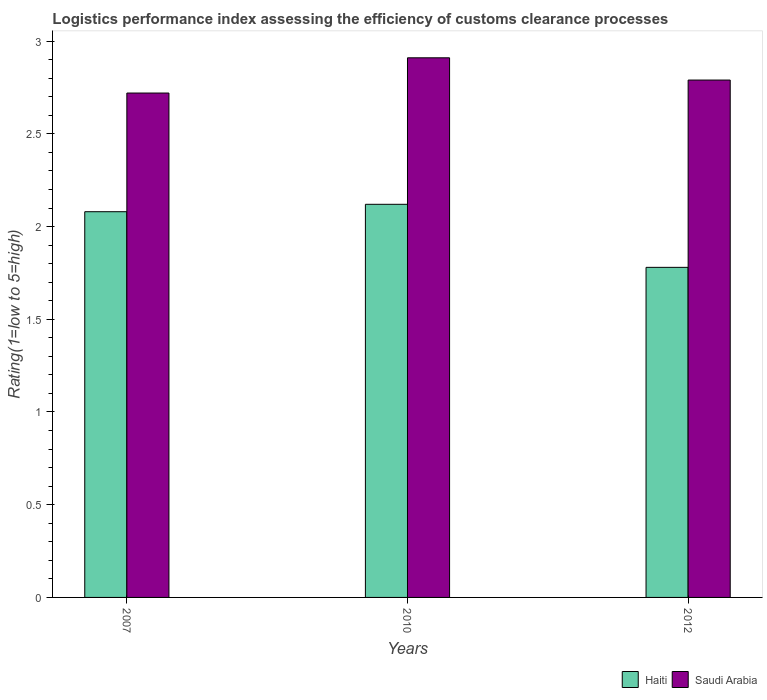How many different coloured bars are there?
Provide a succinct answer. 2. How many bars are there on the 3rd tick from the left?
Offer a very short reply. 2. What is the label of the 2nd group of bars from the left?
Your answer should be very brief. 2010. What is the Logistic performance index in Saudi Arabia in 2012?
Your answer should be compact. 2.79. Across all years, what is the maximum Logistic performance index in Saudi Arabia?
Provide a short and direct response. 2.91. Across all years, what is the minimum Logistic performance index in Haiti?
Give a very brief answer. 1.78. What is the total Logistic performance index in Saudi Arabia in the graph?
Make the answer very short. 8.42. What is the difference between the Logistic performance index in Haiti in 2007 and that in 2010?
Make the answer very short. -0.04. What is the difference between the Logistic performance index in Saudi Arabia in 2010 and the Logistic performance index in Haiti in 2012?
Make the answer very short. 1.13. What is the average Logistic performance index in Saudi Arabia per year?
Provide a succinct answer. 2.81. In the year 2010, what is the difference between the Logistic performance index in Haiti and Logistic performance index in Saudi Arabia?
Your answer should be very brief. -0.79. What is the ratio of the Logistic performance index in Haiti in 2007 to that in 2010?
Ensure brevity in your answer.  0.98. Is the difference between the Logistic performance index in Haiti in 2007 and 2010 greater than the difference between the Logistic performance index in Saudi Arabia in 2007 and 2010?
Give a very brief answer. Yes. What is the difference between the highest and the second highest Logistic performance index in Saudi Arabia?
Offer a terse response. 0.12. What is the difference between the highest and the lowest Logistic performance index in Saudi Arabia?
Your answer should be very brief. 0.19. In how many years, is the Logistic performance index in Haiti greater than the average Logistic performance index in Haiti taken over all years?
Keep it short and to the point. 2. What does the 2nd bar from the left in 2012 represents?
Keep it short and to the point. Saudi Arabia. What does the 2nd bar from the right in 2007 represents?
Offer a terse response. Haiti. How many bars are there?
Your answer should be compact. 6. Are the values on the major ticks of Y-axis written in scientific E-notation?
Provide a succinct answer. No. Where does the legend appear in the graph?
Keep it short and to the point. Bottom right. What is the title of the graph?
Make the answer very short. Logistics performance index assessing the efficiency of customs clearance processes. What is the label or title of the X-axis?
Your response must be concise. Years. What is the label or title of the Y-axis?
Your answer should be very brief. Rating(1=low to 5=high). What is the Rating(1=low to 5=high) of Haiti in 2007?
Your response must be concise. 2.08. What is the Rating(1=low to 5=high) of Saudi Arabia in 2007?
Provide a short and direct response. 2.72. What is the Rating(1=low to 5=high) of Haiti in 2010?
Offer a very short reply. 2.12. What is the Rating(1=low to 5=high) of Saudi Arabia in 2010?
Offer a terse response. 2.91. What is the Rating(1=low to 5=high) in Haiti in 2012?
Your response must be concise. 1.78. What is the Rating(1=low to 5=high) of Saudi Arabia in 2012?
Provide a succinct answer. 2.79. Across all years, what is the maximum Rating(1=low to 5=high) of Haiti?
Offer a very short reply. 2.12. Across all years, what is the maximum Rating(1=low to 5=high) in Saudi Arabia?
Provide a short and direct response. 2.91. Across all years, what is the minimum Rating(1=low to 5=high) in Haiti?
Ensure brevity in your answer.  1.78. Across all years, what is the minimum Rating(1=low to 5=high) of Saudi Arabia?
Offer a terse response. 2.72. What is the total Rating(1=low to 5=high) of Haiti in the graph?
Keep it short and to the point. 5.98. What is the total Rating(1=low to 5=high) in Saudi Arabia in the graph?
Keep it short and to the point. 8.42. What is the difference between the Rating(1=low to 5=high) in Haiti in 2007 and that in 2010?
Keep it short and to the point. -0.04. What is the difference between the Rating(1=low to 5=high) in Saudi Arabia in 2007 and that in 2010?
Provide a short and direct response. -0.19. What is the difference between the Rating(1=low to 5=high) in Saudi Arabia in 2007 and that in 2012?
Your response must be concise. -0.07. What is the difference between the Rating(1=low to 5=high) in Haiti in 2010 and that in 2012?
Your response must be concise. 0.34. What is the difference between the Rating(1=low to 5=high) in Saudi Arabia in 2010 and that in 2012?
Provide a succinct answer. 0.12. What is the difference between the Rating(1=low to 5=high) of Haiti in 2007 and the Rating(1=low to 5=high) of Saudi Arabia in 2010?
Provide a short and direct response. -0.83. What is the difference between the Rating(1=low to 5=high) in Haiti in 2007 and the Rating(1=low to 5=high) in Saudi Arabia in 2012?
Offer a very short reply. -0.71. What is the difference between the Rating(1=low to 5=high) of Haiti in 2010 and the Rating(1=low to 5=high) of Saudi Arabia in 2012?
Offer a very short reply. -0.67. What is the average Rating(1=low to 5=high) in Haiti per year?
Keep it short and to the point. 1.99. What is the average Rating(1=low to 5=high) of Saudi Arabia per year?
Your response must be concise. 2.81. In the year 2007, what is the difference between the Rating(1=low to 5=high) in Haiti and Rating(1=low to 5=high) in Saudi Arabia?
Give a very brief answer. -0.64. In the year 2010, what is the difference between the Rating(1=low to 5=high) of Haiti and Rating(1=low to 5=high) of Saudi Arabia?
Offer a very short reply. -0.79. In the year 2012, what is the difference between the Rating(1=low to 5=high) of Haiti and Rating(1=low to 5=high) of Saudi Arabia?
Give a very brief answer. -1.01. What is the ratio of the Rating(1=low to 5=high) in Haiti in 2007 to that in 2010?
Offer a terse response. 0.98. What is the ratio of the Rating(1=low to 5=high) of Saudi Arabia in 2007 to that in 2010?
Keep it short and to the point. 0.93. What is the ratio of the Rating(1=low to 5=high) of Haiti in 2007 to that in 2012?
Offer a very short reply. 1.17. What is the ratio of the Rating(1=low to 5=high) of Saudi Arabia in 2007 to that in 2012?
Your answer should be very brief. 0.97. What is the ratio of the Rating(1=low to 5=high) of Haiti in 2010 to that in 2012?
Your answer should be compact. 1.19. What is the ratio of the Rating(1=low to 5=high) of Saudi Arabia in 2010 to that in 2012?
Keep it short and to the point. 1.04. What is the difference between the highest and the second highest Rating(1=low to 5=high) of Saudi Arabia?
Your response must be concise. 0.12. What is the difference between the highest and the lowest Rating(1=low to 5=high) of Haiti?
Give a very brief answer. 0.34. What is the difference between the highest and the lowest Rating(1=low to 5=high) in Saudi Arabia?
Ensure brevity in your answer.  0.19. 